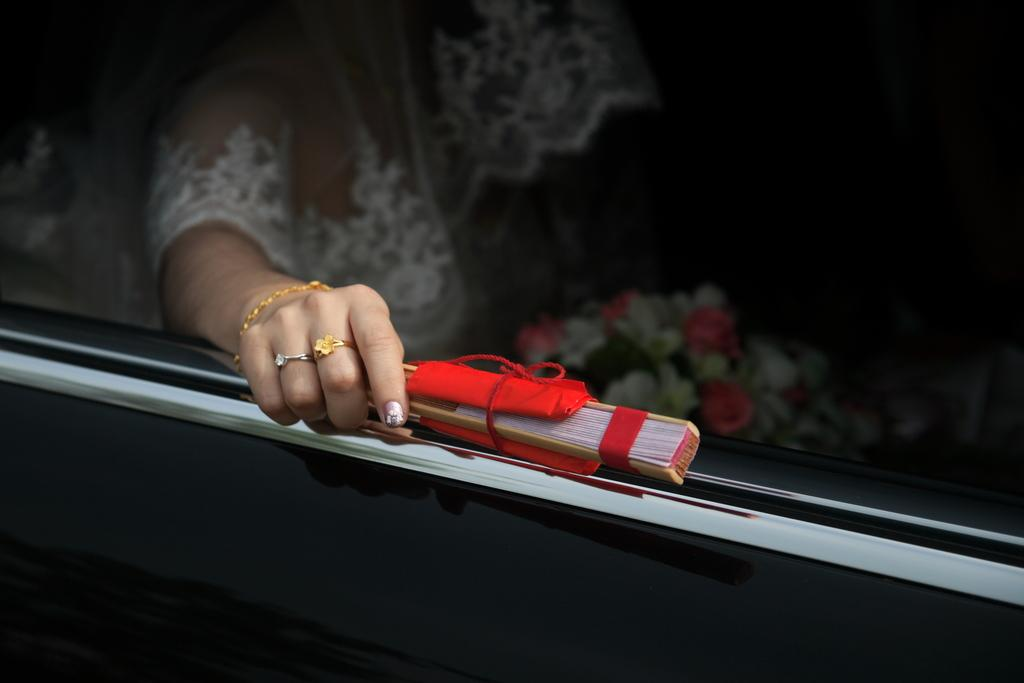What is the main subject of the image? There is a vehicle in the image. Who is inside the vehicle? There is a woman sitting in the vehicle. What is the woman holding in the image? The woman is holding a flower bouquet and some sticks. What type of ghost can be seen in the image? There is no ghost present in the image. Is there a camp or church visible in the image? No, there is no camp or church visible in the image. 